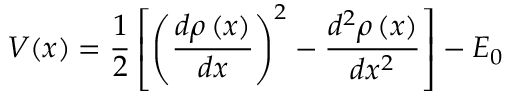Convert formula to latex. <formula><loc_0><loc_0><loc_500><loc_500>V ( x ) = \frac { 1 } { 2 } \left [ \left ( \frac { d \rho \left ( x \right ) } { d x } \right ) ^ { 2 } - \frac { d ^ { 2 } \rho \left ( x \right ) } { d x ^ { 2 } } \right ] - E _ { 0 }</formula> 